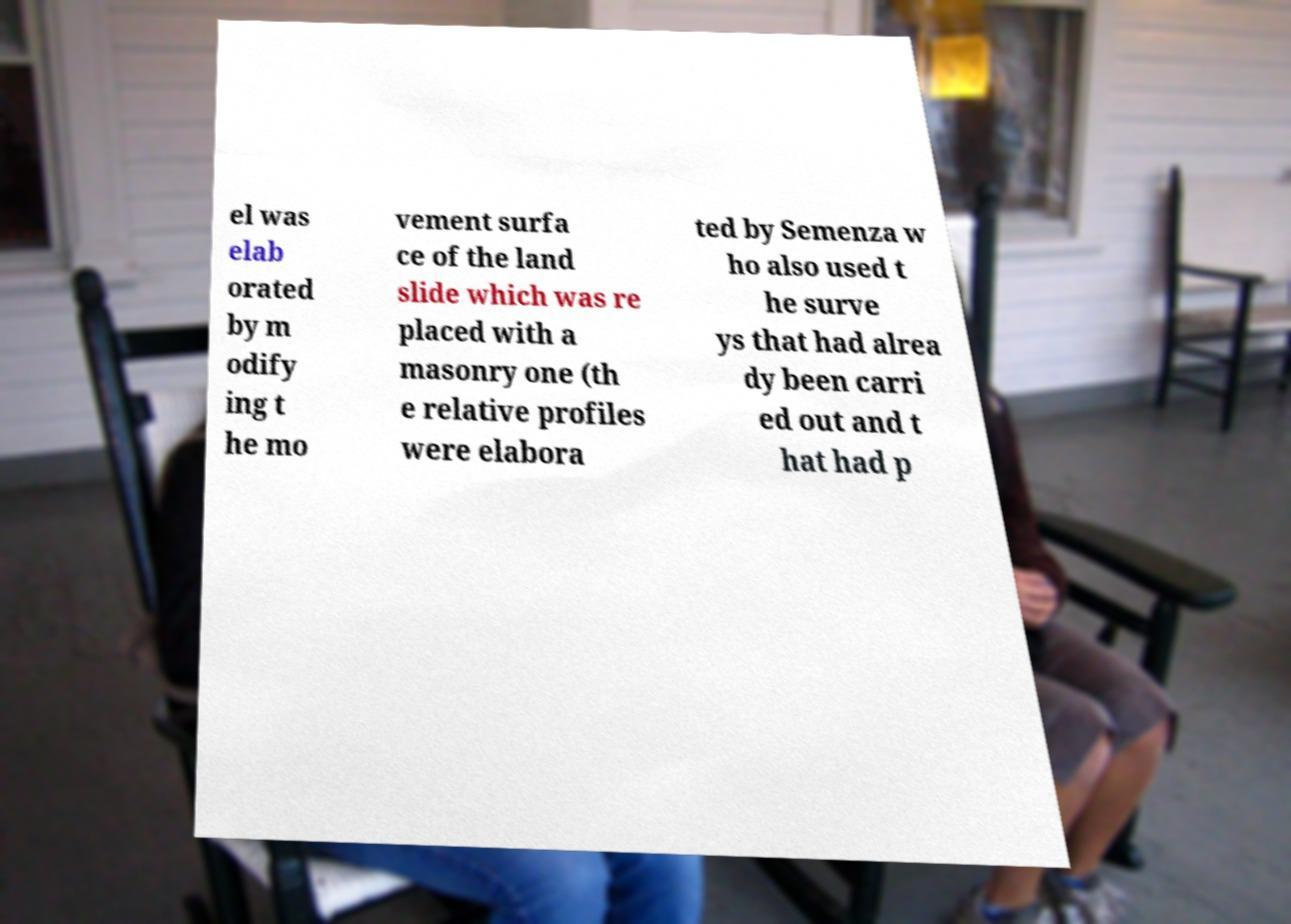Please read and relay the text visible in this image. What does it say? el was elab orated by m odify ing t he mo vement surfa ce of the land slide which was re placed with a masonry one (th e relative profiles were elabora ted by Semenza w ho also used t he surve ys that had alrea dy been carri ed out and t hat had p 